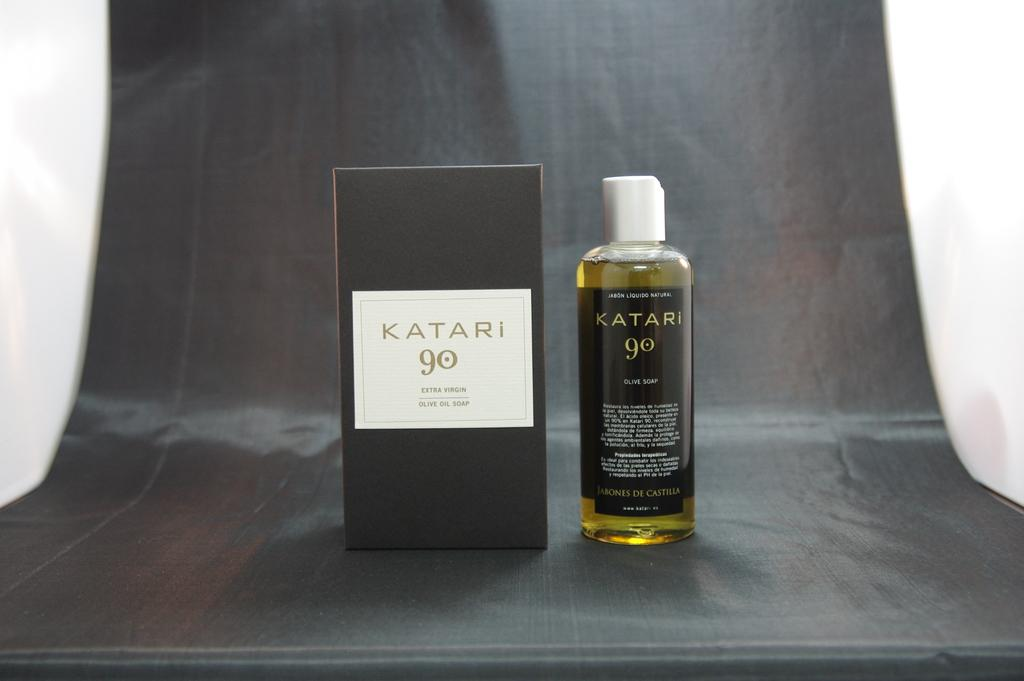<image>
Provide a brief description of the given image. A bottle of Katari 90 olive soap is to the right of its box. 